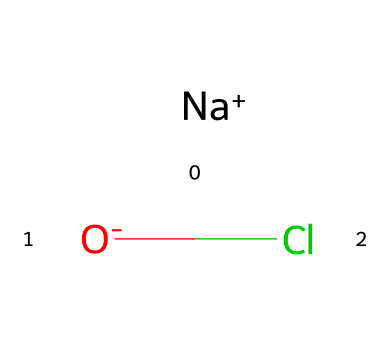What is the molecular formula of sodium hypochlorite? This chemical is represented in SMILES as [Na+].[O-]Cl, indicating that it consists of sodium (Na), oxygen (O), and chlorine (Cl). Therefore, the molecular formula is NaOCl.
Answer: NaOCl How many different elements are present in sodium hypochlorite? In the SMILES representation [Na+].[O-]Cl, we can identify three distinct elements: sodium (Na), oxygen (O), and chlorine (Cl). Counting these gives us 3 different elements.
Answer: 3 What kind of bond exists between sodium and hypochlorite in this chemical? The representation suggests that sodium (Na) is ionically bonded to the hypochlorite ion (OCl-). This bond occurs because sodium donates an electron to form a positive ion, while hypochlorite is a negatively charged ion, leading to an ionic bond.
Answer: ionic Is sodium hypochlorite an oxidizer? Sodium hypochlorite is classified as an oxidizer; its structure includes an oxygen atom bonded to chlorine, which can readily release oxygen and facilitate oxidation reactions.
Answer: Yes What charge does the hypochlorite ion have? From the SMILES depiction [Na+].[O-]Cl, it can be inferred that the hypochlorite ion carries a negative charge, as indicated by the presence of the oxygen atom with a negative sign.
Answer: negative How does the presence of oxygen in sodium hypochlorite contribute to its reactivity? The presence of oxygen in sodium hypochlorite enables it to act as a strong oxidizing agent, which enhances its ability to participate in chemical reactions that involve the transfer of electrons from other substances. This reactivity is central to its role in disinfection.
Answer: enhances reactivity 